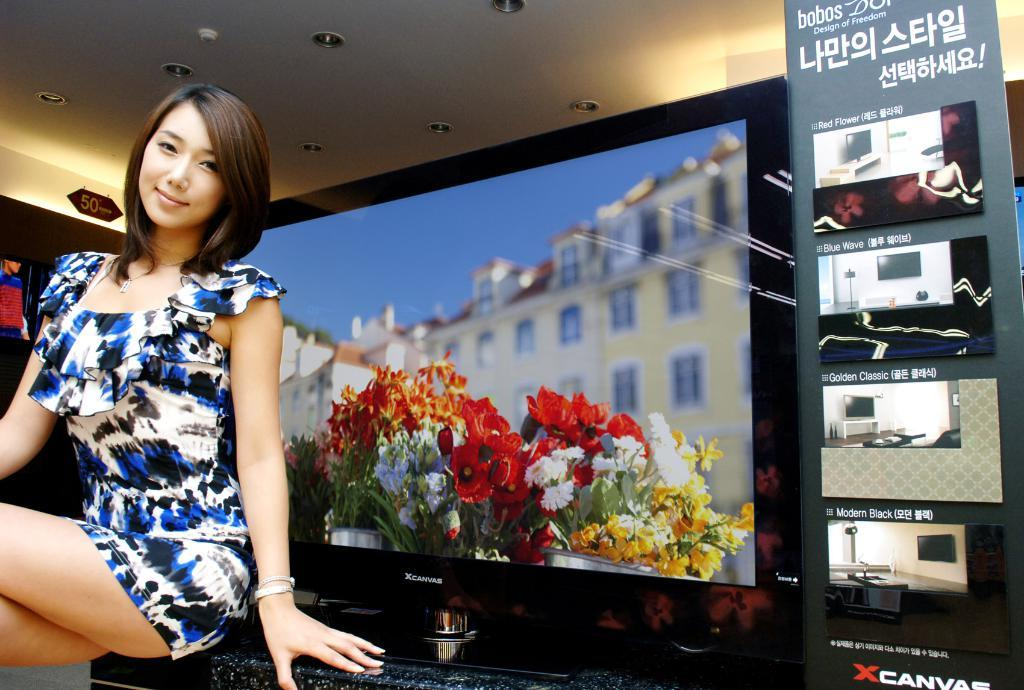<image>
Render a clear and concise summary of the photo. A girl is sitting in front of a XCanvas tv screen that has an image with colorful flowers in it. 